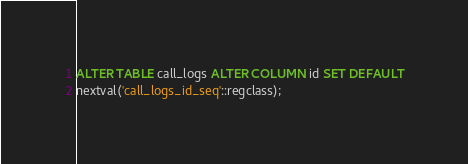Convert code to text. <code><loc_0><loc_0><loc_500><loc_500><_SQL_>
ALTER TABLE call_logs ALTER COLUMN id SET DEFAULT
nextval('call_logs_id_seq'::regclass);</code> 